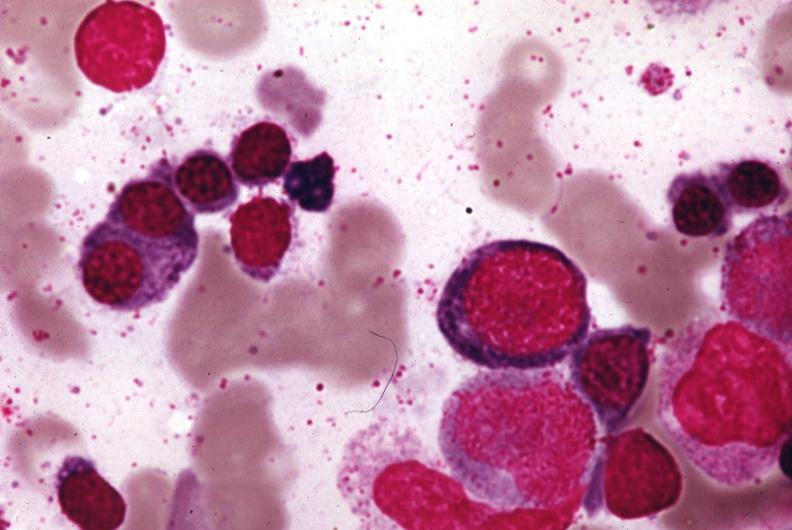s leg present?
Answer the question using a single word or phrase. No 